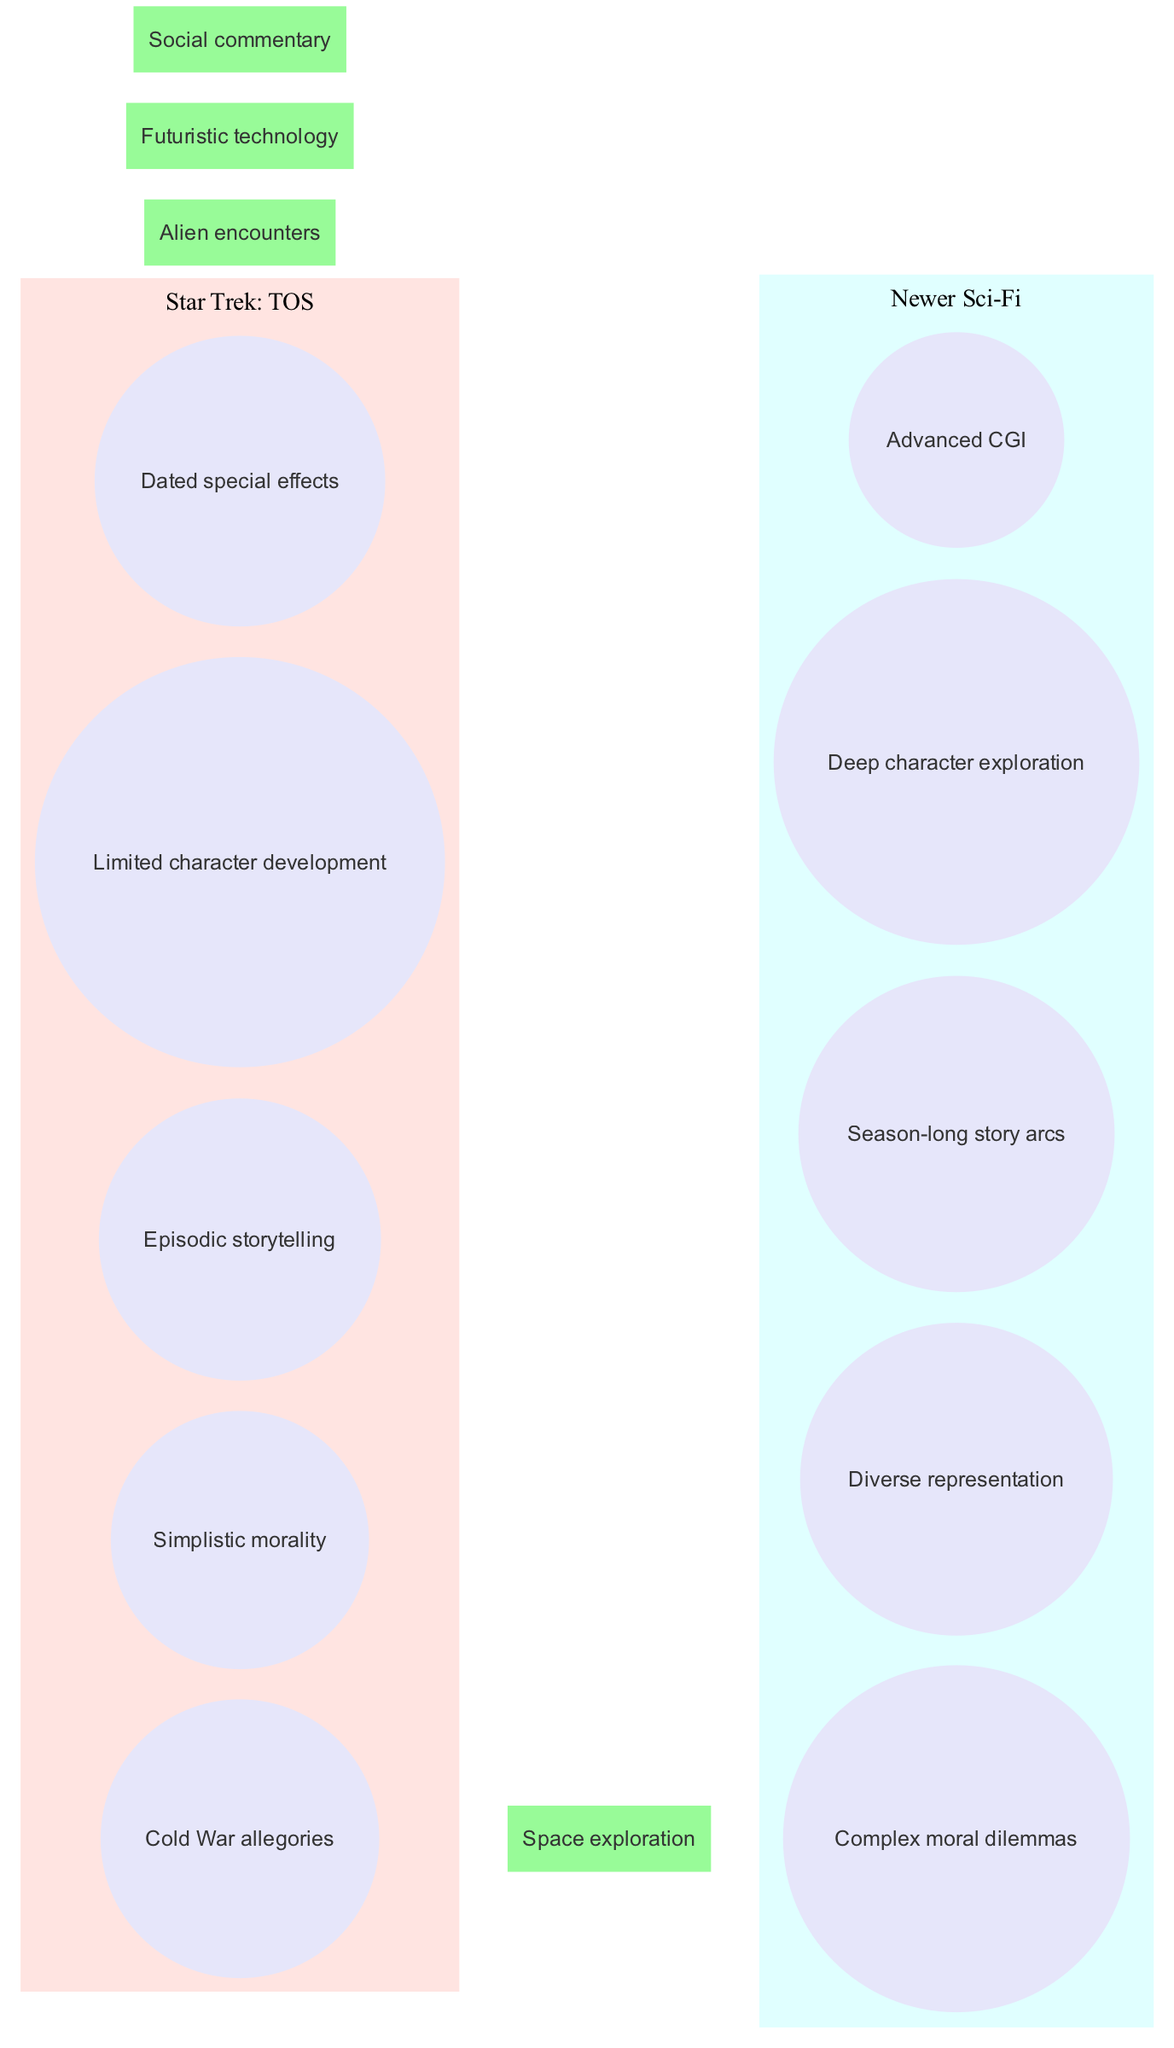What themes are unique to Star Trek: TOS? The unique themes found in the Star Trek: TOS set, as shown in the diagram, include "Cold War allegories," "Simplistic morality," "Episodic storytelling," "Limited character development," and "Dated special effects." These elements are listed exclusively within the Star Trek: TOS circle, indicating they are not shared with newer sci-fi productions.
Answer: Cold War allegories, Simplistic morality, Episodic storytelling, Limited character development, Dated special effects What is the number of themes explored in newer sci-fi productions? In the newer sci-fi productions circle of the diagram, there are five themes listed: "Complex moral dilemmas," "Diverse representation," "Season-long story arcs," "Deep character exploration," and "Advanced CGI." To find the answer, we count the elements in this section.
Answer: 5 What themes do Star Trek: TOS and newer sci-fi productions have in common? The intersection of the two circles reveals shared themes, which include "Space exploration," "Alien encounters," "Futuristic technology," and "Social commentary." To answer, we simply refer to the intersection section of the diagram.
Answer: Space exploration, Alien encounters, Futuristic technology, Social commentary Which theme is associated with newer sci-fi productions but not Star Trek: TOS? The diagram highlights "Complex moral dilemmas," "Diverse representation," "Season-long story arcs," "Deep character exploration," and "Advanced CGI" as themes exclusive to newer sci-fi productions. These themes do not appear in Star Trek: TOS, and we can identify one of them to answer the question.
Answer: Complex moral dilemmas How many total themes are represented in the intersection? The intersection has four themes shared between Star Trek: TOS and newer sci-fi productions. To count them, we can simply list the themes found in that area of the diagram: "Space exploration," "Alien encounters," "Futuristic technology," and "Social commentary."
Answer: 4 What visual structure is used in this diagram? The diagram adopts a Venn diagram structure, which effectively conveys the comparison between two sets and their overlapping themes. The circular representation allows for visual clarity in distinguishing between unique and shared themes.
Answer: Venn diagram 